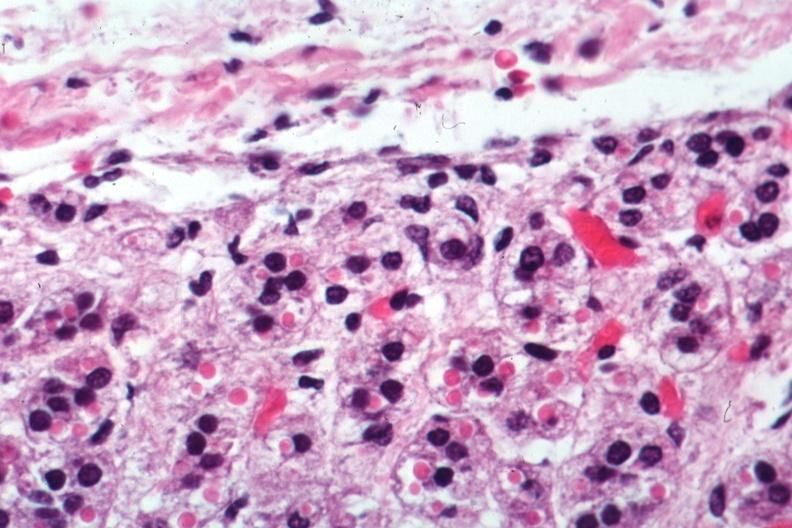s endocrine present?
Answer the question using a single word or phrase. Yes 